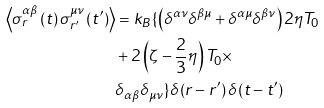Convert formula to latex. <formula><loc_0><loc_0><loc_500><loc_500>\left \langle \sigma _ { r } ^ { \alpha \beta } \left ( t \right ) \sigma _ { r ^ { \prime } } ^ { \mu \nu } \left ( t ^ { \prime } \right ) \right \rangle & = k _ { B } \{ \left ( \delta ^ { \alpha \nu } \delta ^ { \beta \mu } + \delta ^ { \alpha \mu } \delta ^ { \beta \nu } \right ) 2 \eta T _ { 0 } \\ & + 2 \left ( \zeta - \frac { 2 } { 3 } \eta \right ) T _ { 0 } \times \\ & \delta _ { \alpha \beta } \delta _ { \mu \nu } \} \delta \left ( r - r ^ { \prime } \right ) \delta \left ( t - t ^ { \prime } \right )</formula> 